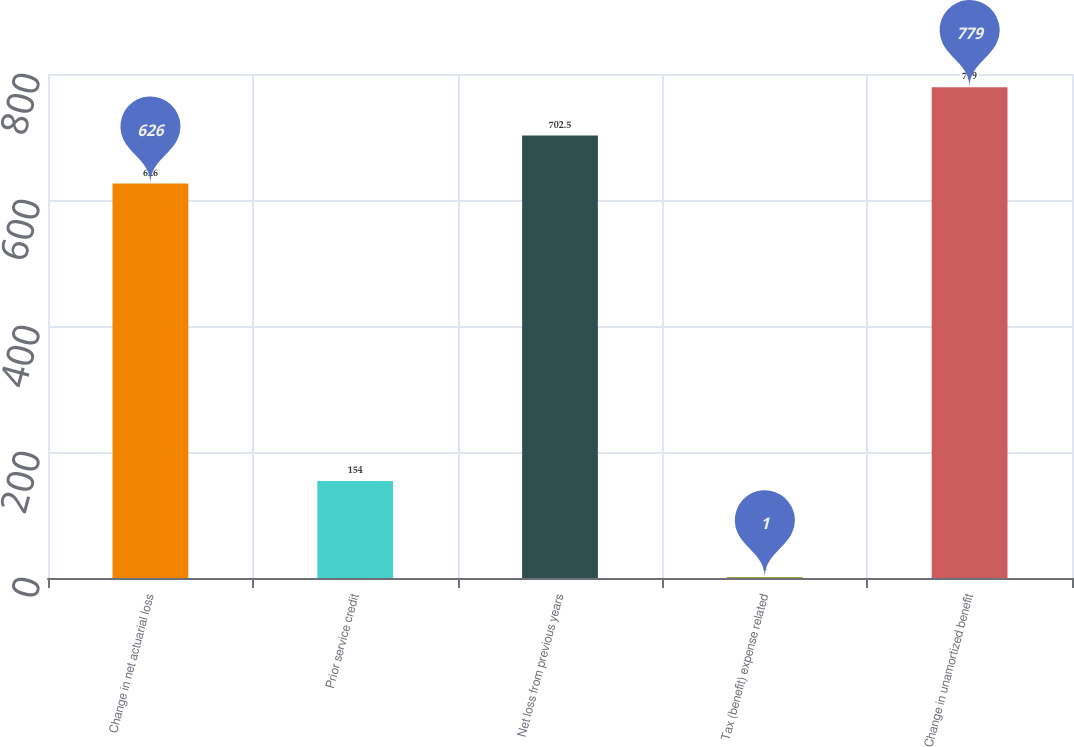Convert chart. <chart><loc_0><loc_0><loc_500><loc_500><bar_chart><fcel>Change in net actuarial loss<fcel>Prior service credit<fcel>Net loss from previous years<fcel>Tax (benefit) expense related<fcel>Change in unamortized benefit<nl><fcel>626<fcel>154<fcel>702.5<fcel>1<fcel>779<nl></chart> 